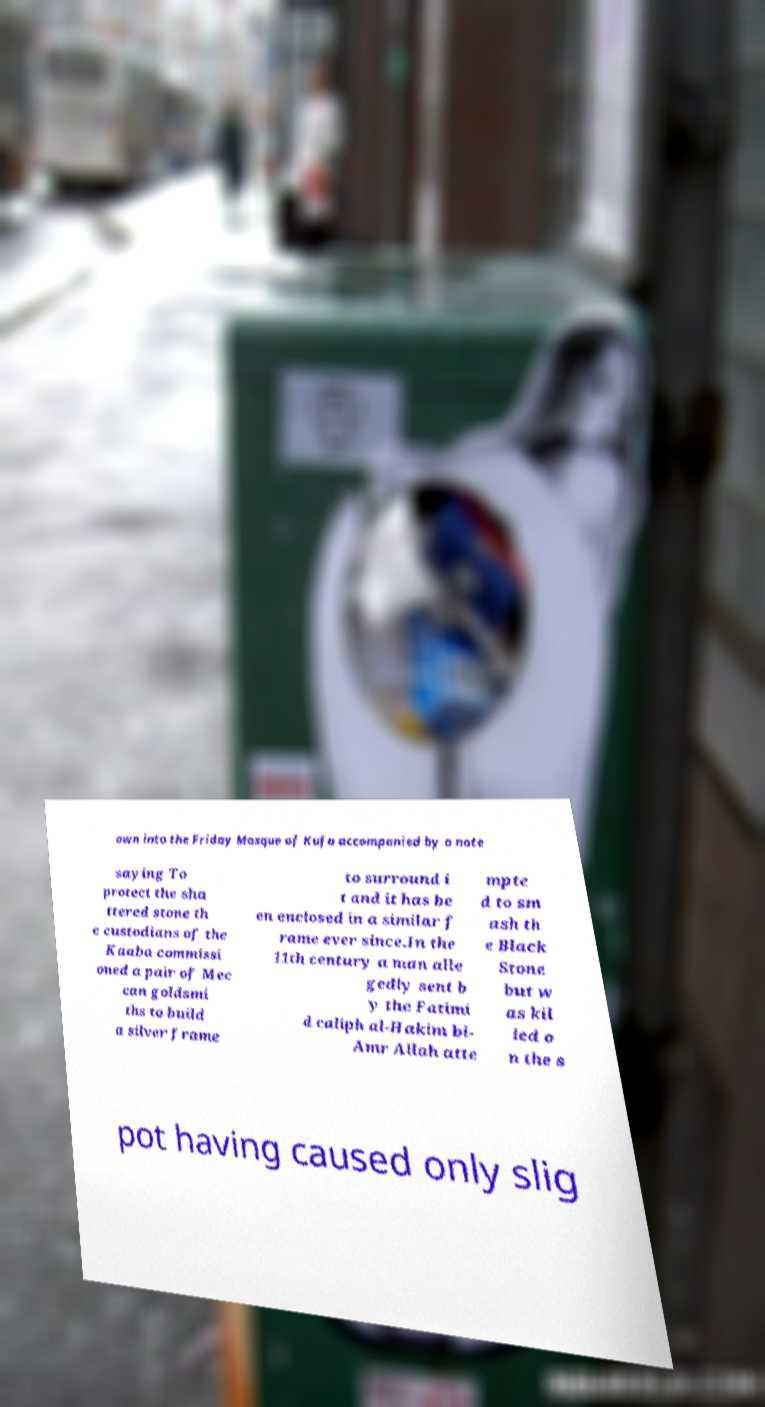I need the written content from this picture converted into text. Can you do that? own into the Friday Mosque of Kufa accompanied by a note saying To protect the sha ttered stone th e custodians of the Kaaba commissi oned a pair of Mec can goldsmi ths to build a silver frame to surround i t and it has be en enclosed in a similar f rame ever since.In the 11th century a man alle gedly sent b y the Fatimi d caliph al-Hakim bi- Amr Allah atte mpte d to sm ash th e Black Stone but w as kil led o n the s pot having caused only slig 